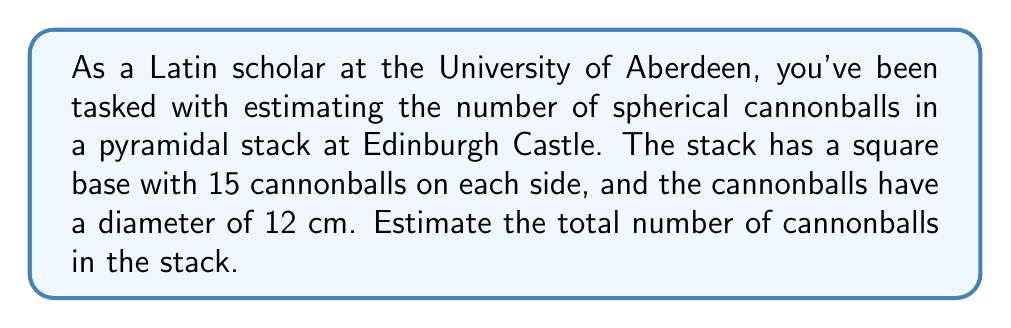Can you solve this math problem? Let's approach this step-by-step:

1) In a pyramidal stack, the number of cannonballs in each layer forms a square number sequence:
   $1^2, 2^2, 3^2, ..., n^2$

2) The total number of cannonballs is the sum of this sequence, where $n$ is the number of cannonballs on one side of the base.

3) The sum of square numbers is given by the formula:
   $$\sum_{k=1}^n k^2 = \frac{n(n+1)(2n+1)}{6}$$

4) In this case, $n = 15$ (the number of cannonballs on each side of the base).

5) Plugging this into our formula:
   $$\text{Total cannonballs} = \frac{15(15+1)(2\cdot15+1)}{6}$$
   $$= \frac{15 \cdot 16 \cdot 31}{6}$$
   $$= \frac{7440}{6} = 1240$$

6) Therefore, the estimated number of cannonballs in the stack is 1240.

Note: This calculation assumes perfect stacking and uniform size of cannonballs, which may not be exactly true in reality, hence it's an estimate.
Answer: 1240 cannonballs 